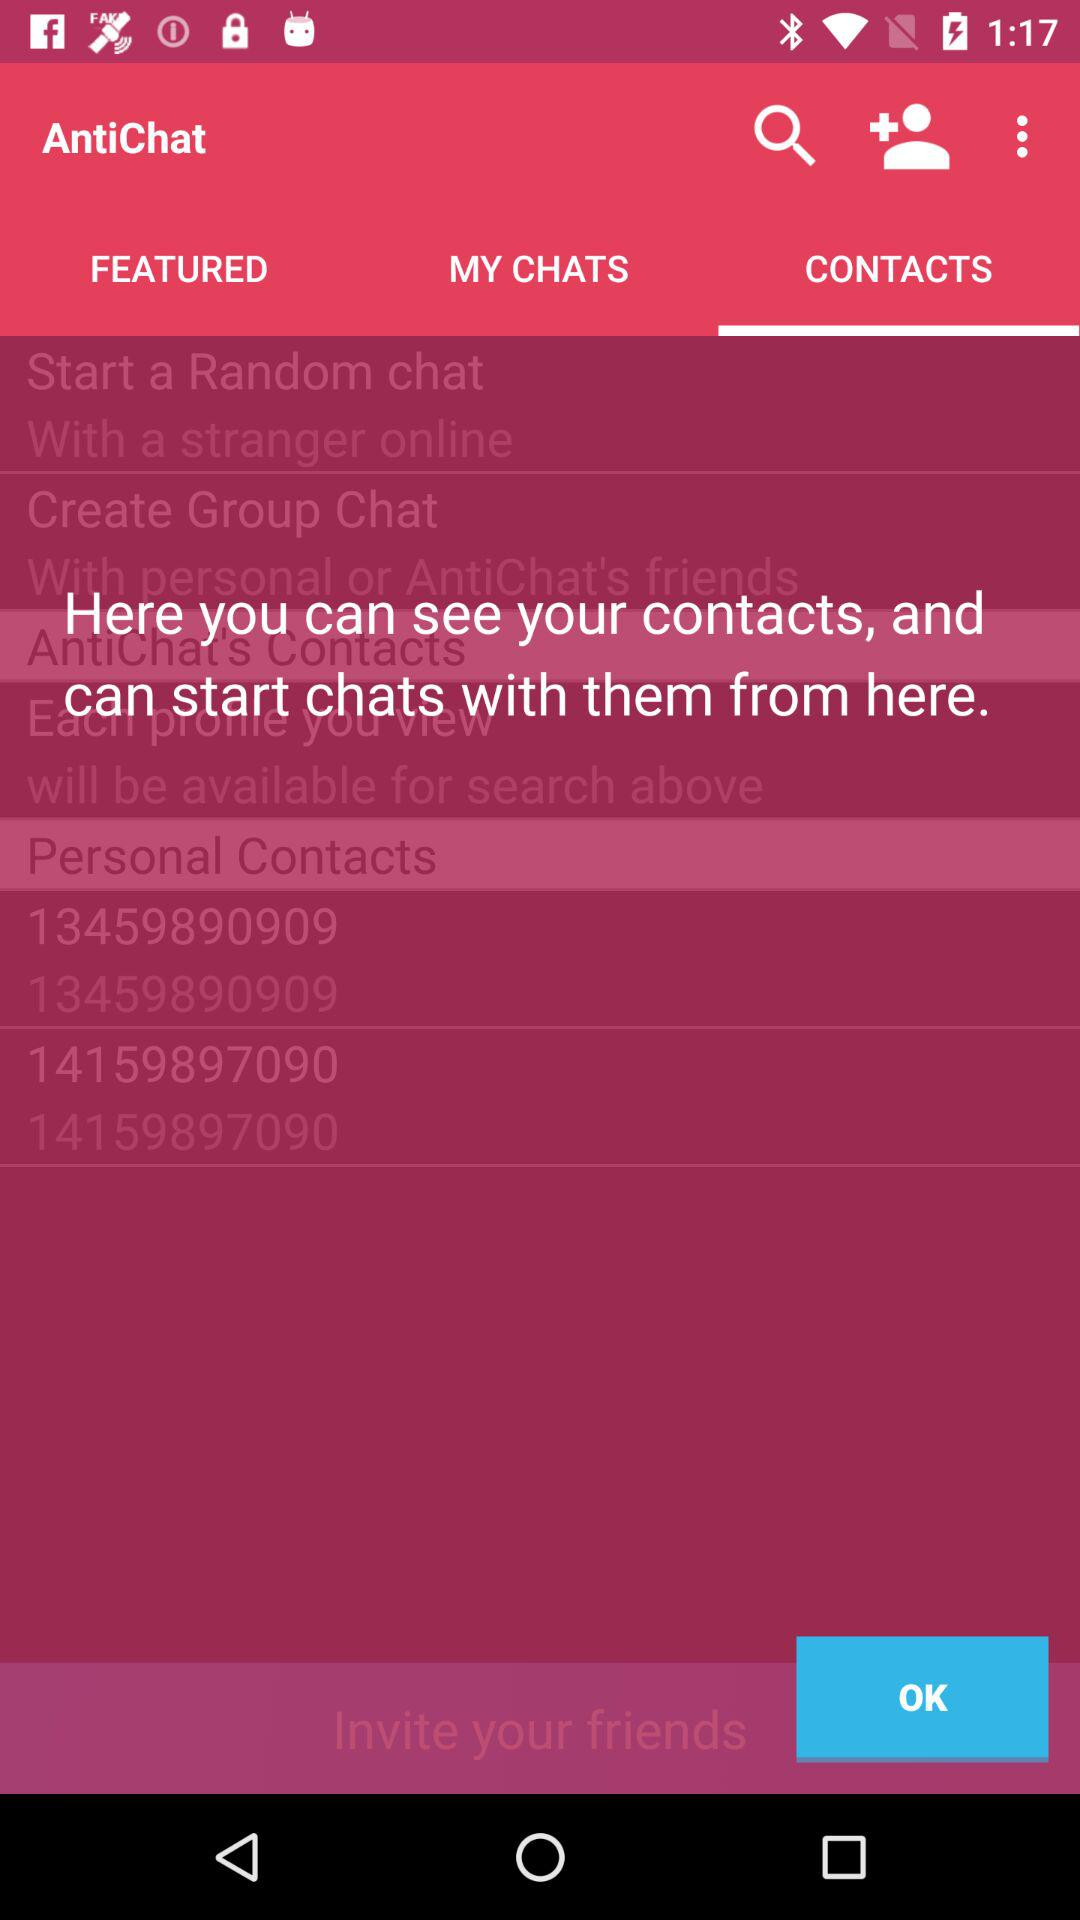What is the name of the application? The name of the application is "AntiChat". 